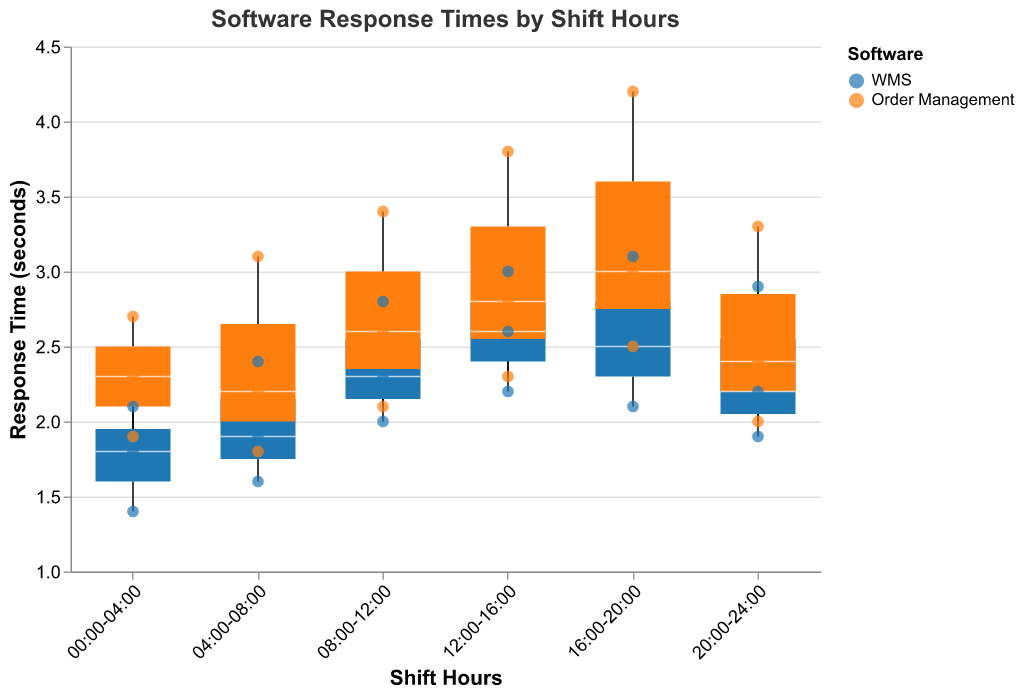What is the title of the plot? The title is displayed prominently at the top of the figure. It reads "Software Response Times by Shift Hours".
Answer: Software Response Times by Shift Hours Which software has a lower median response time during 00:00-04:00? Examine the central line within each boxplot for the shift 00:00-04:00. The median response time for WMS is lower than that of Order Management.
Answer: WMS What is the range of response times for Order Management software during 08:00-12:00? Look at the minimum and maximum points of the whiskers of the boxplot for Order Management during 08:00-12:00. The range is from 2.1 to 3.4 seconds.
Answer: 2.1 to 3.4 seconds Which shift hour has the highest median response time for any software? Check the medians of each boxplot across different shift hours. The highest median response time is seen in the 16:00-20:00 shift for Order Management software.
Answer: 16:00-20:00 What is the interquartile range (IQR) of WMS software response times during 12:00-16:00? The IQR is the range between the first quartile (Q1) and the third quartile (Q3) of the boxplot. For WMS during 12:00-16:00, Q1 is around 2.2 and Q3 is around 3.0. Therefore, the IQR is 3.0 - 2.2 = 0.8 seconds.
Answer: 0.8 seconds How does the variability in response times for Order Management compare between the shifts 00:00-04:00 and 16:00-20:00? The variability can be assessed by the length of the box (IQR) and the whiskers (range). For 00:00-04:00, the IQR and range are smaller compared to 16:00-20:00, indicating less variability during the earlier shift.
Answer: Less variability in 00:00-04:00 Are there any shifts where the response time of Order Management exceeds 4 seconds? Look for any data points or whiskers extending beyond 4 seconds. In the shift 16:00-20:00, the response time for Order Management exceeds 4 seconds, reaching up to 4.2 seconds.
Answer: Yes, 16:00-20:00 What is the lowest recorded response time across all shifts for WMS? Identify the lowest point on the whiskers of any WMS boxplot. The lowest recorded response time for WMS is 1.4 seconds during the 00:00-04:00 shift.
Answer: 1.4 seconds Which software shows greater variability in response times during the 04:00-08:00 shift? Compare the length of the box (IQR) and whiskers for both WMS and Order Management during this shift. Order Management shows greater variability with a wider IQR and longer whiskers.
Answer: Order Management During which shift hour do both software systems have the closest median response times? Look at the medians in each boxplot and compare the differences. Close medians are observed during the shift 20:00-24:00 for WMS and Order Management.
Answer: 20:00-24:00 